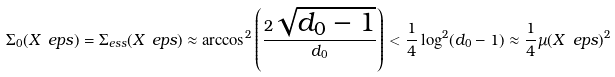<formula> <loc_0><loc_0><loc_500><loc_500>\Sigma _ { 0 } ( X _ { \ } e p s ) = \Sigma _ { e s s } ( X _ { \ } e p s ) \approx \arccos ^ { 2 } \left ( \frac { 2 \sqrt { d _ { 0 } - 1 } } { d _ { 0 } } \right ) < \frac { 1 } { 4 } \log ^ { 2 } ( d _ { 0 } - 1 ) \approx \frac { 1 } { 4 } \mu ( X _ { \ } e p s ) ^ { 2 }</formula> 